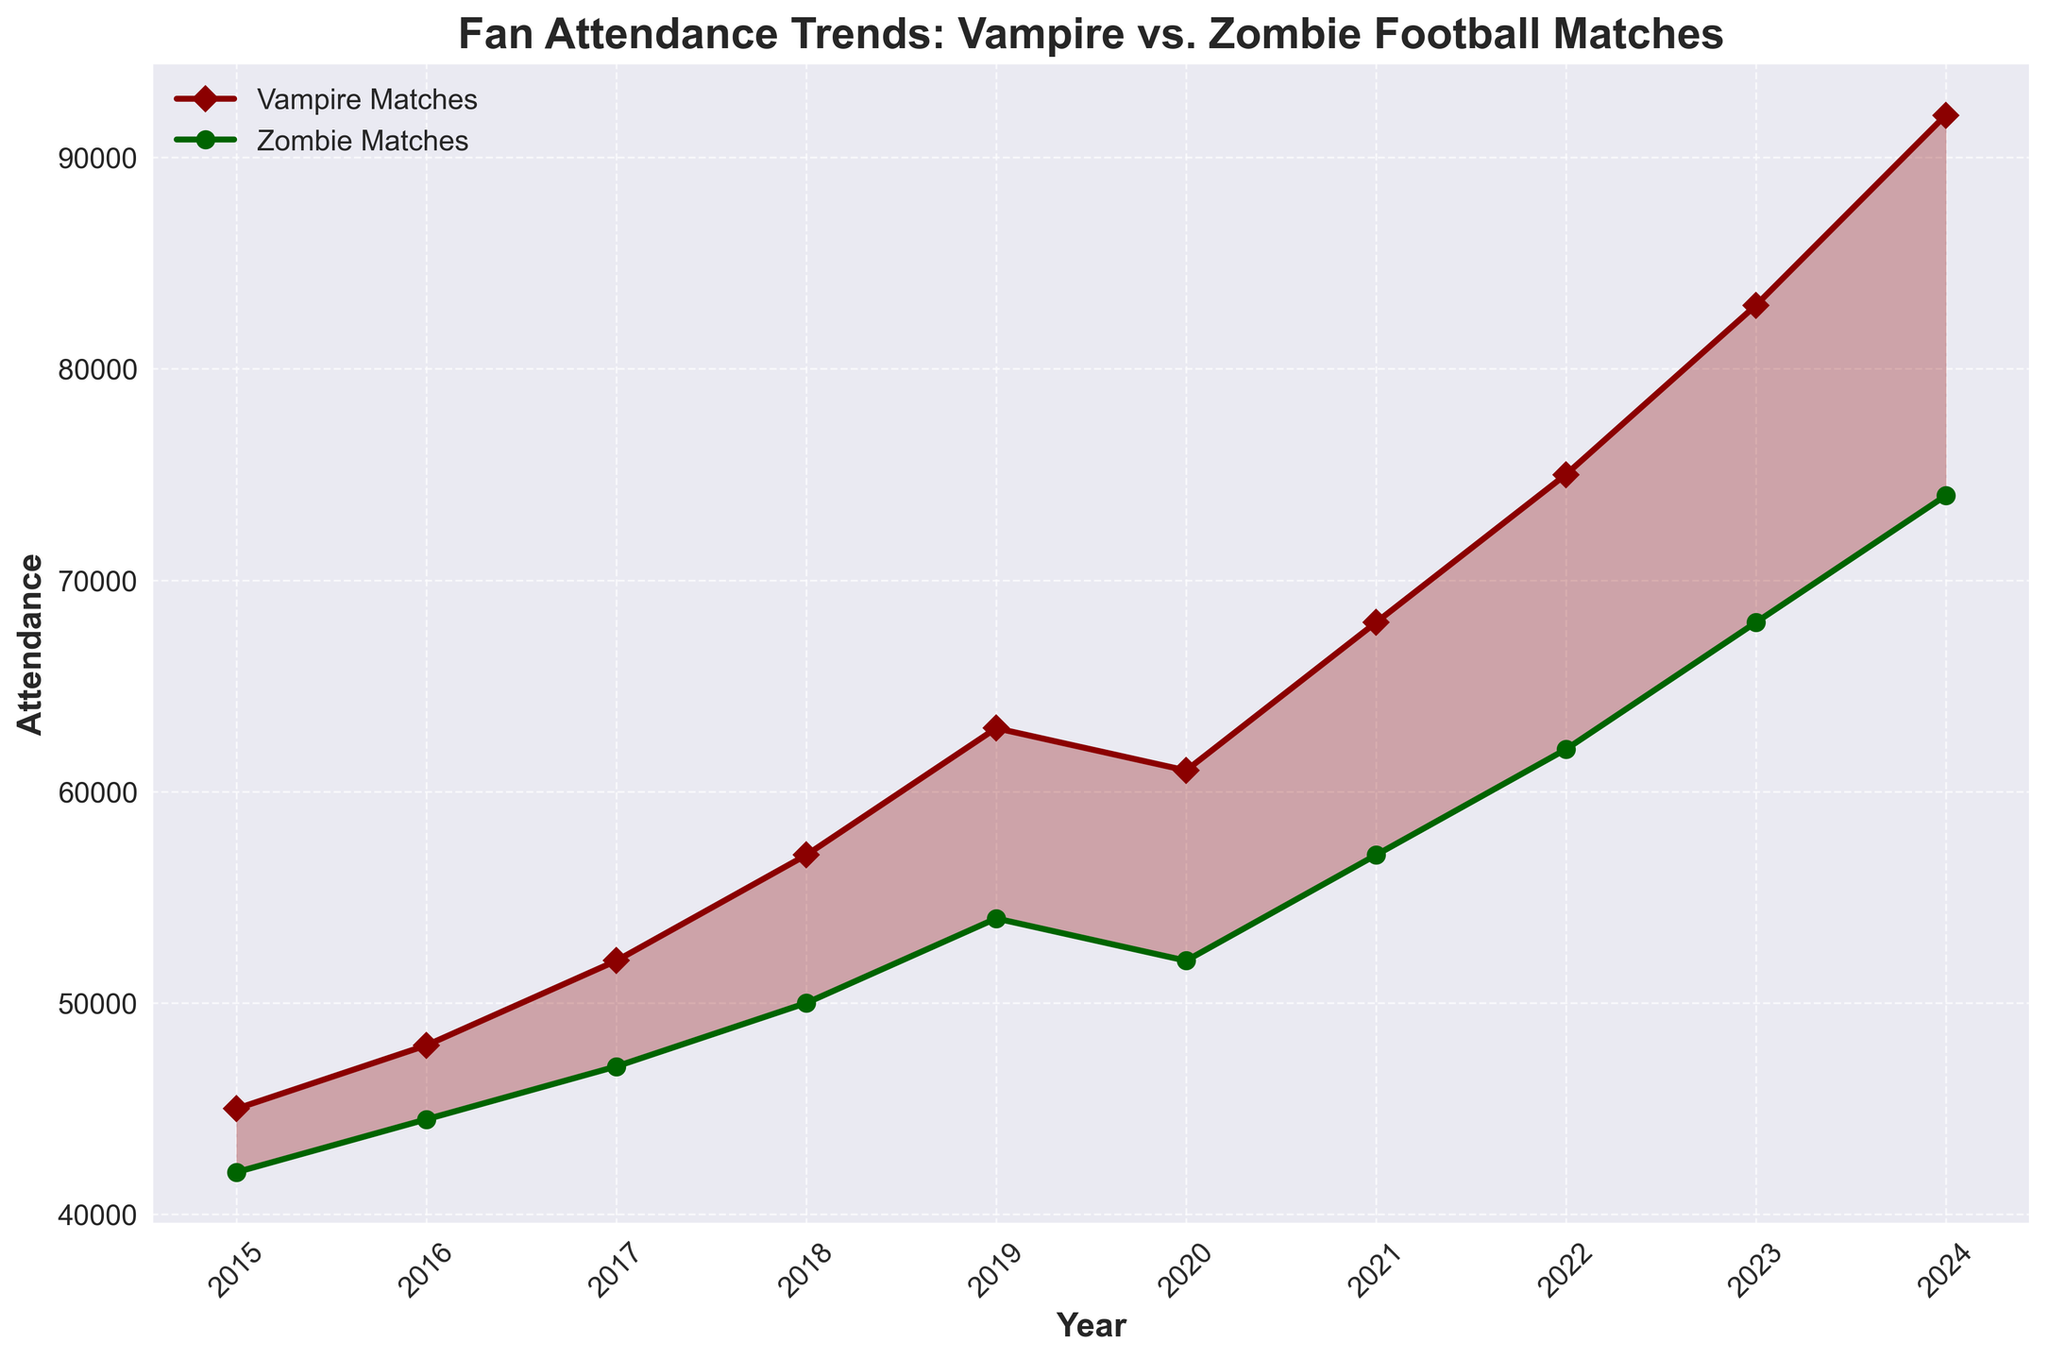What was the attendance for vampire and zombie matches in 2020? To find the attendance for both vampire and zombie matches in 2020, check the values on the line chart for the year 2020.
Answer: Vampire: 61,000, Zombie: 52,000 Which category showed higher attendance in 2023, and by how much? Compare the values for 2023 on the chart for both vampire and zombie matches. Vampire matches had 83,000 attendees, while zombie matches had 68,000 attendees.
Answer: Vampire by 15,000 In which year did the vampire matches start showing a significant lead in attendance over zombie matches? Look for the year when the gap between the vampire and zombie attendance lines starts to widen significantly more.
Answer: 2019 Calculate the average attendance for vampire matches from 2015 to 2024. Sum the vampire match attendances for each year and divide by the total number of years (10). (45,000 + 48,000 + 52,000 + 57,000 + 63,000 + 61,000 + 68,000 + 75,000 + 83,000 + 92,000)/10
Answer: 64,400 What is the most noticeable visual element used to indicate vampire superiority in attendance? Identify the visual elements used in the chart, particularly those used to show trends or comparisons.
Answer: Shaded red area between the lines From 2016 to 2017, did the attendance for zombie matches increase or decrease, and by how much? Check the values for zombie matches in 2016 and 2017. Subtract the 2016 value from the 2017 value to find the difference. 47,000 - 44,500
Answer: Increase by 2,500 Estimate the slope of the attendance trend for vampire matches between 2022 and 2024. Evaluate the change in attendance from 2022 to 2024 and divide by the number of years (2). (92,000 - 75,000)/2
Answer: 8,500 per year During which year did zombie matches have an attendance of 62,000? Locate the value of 62,000 in the zombie attendance line and find the corresponding year.
Answer: 2022 How much did vampire match attendance increase from the previous year in 2021? Subtract the attendance for 2020 from the attendance for 2021 for vampire matches. 68,000 - 61,000
Answer: 7,000 